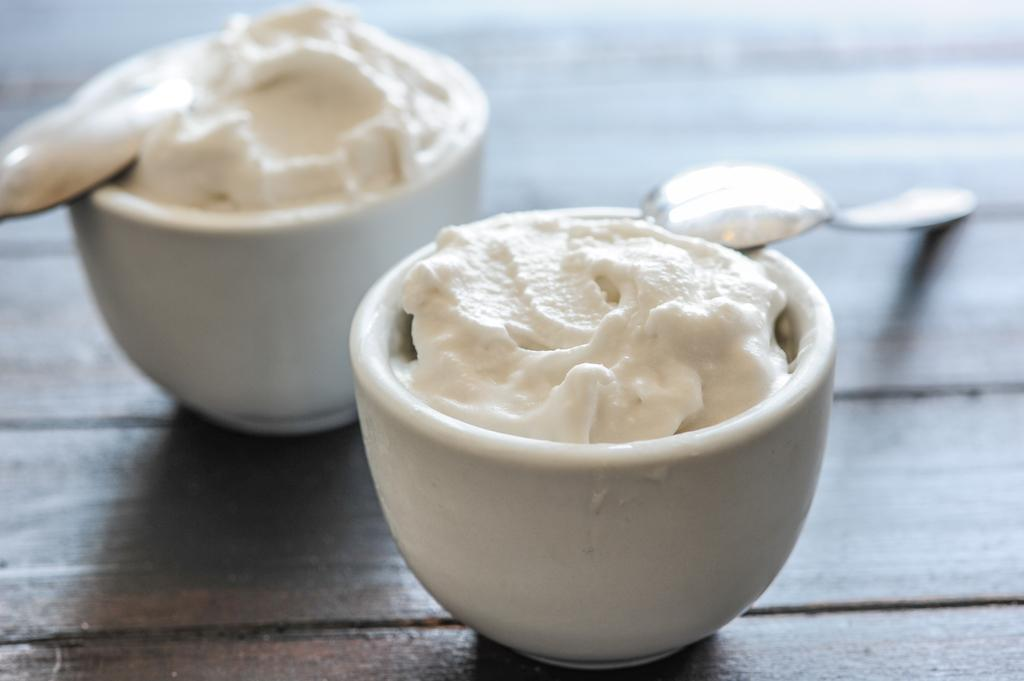What type of table is in the image? There is a wooden table in the image. What objects are on the table? There are bowls and spoons on the table. What is the nature of the food item on the table? The food item on the table is not specified, but it is present. How is the top part of the image described? The top part of the image is blurred. What type of society is depicted in the image? There is no society depicted in the image; it features a wooden table with bowls, spoons, and a food item. Where is the faucet located in the image? There is no faucet present in the image. 